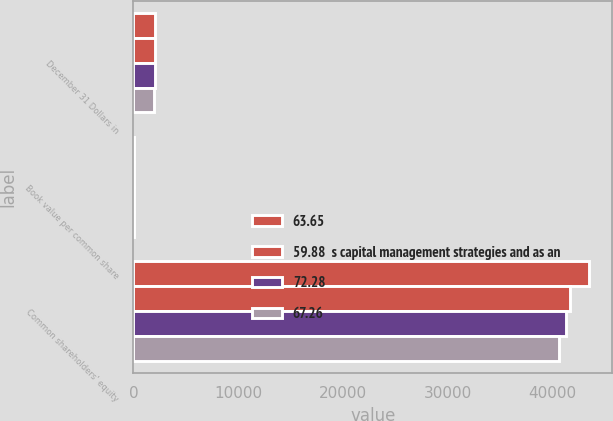Convert chart to OTSL. <chart><loc_0><loc_0><loc_500><loc_500><stacked_bar_chart><ecel><fcel>December 31 Dollars in<fcel>Book value per common share<fcel>Common shareholders' equity<nl><fcel>63.65<fcel>2017<fcel>91.94<fcel>43530<nl><fcel>59.88  s capital management strategies and as an<fcel>2016<fcel>85.94<fcel>41723<nl><fcel>72.28<fcel>2015<fcel>81.84<fcel>41258<nl><fcel>67.26<fcel>2014<fcel>77.61<fcel>40605<nl></chart> 